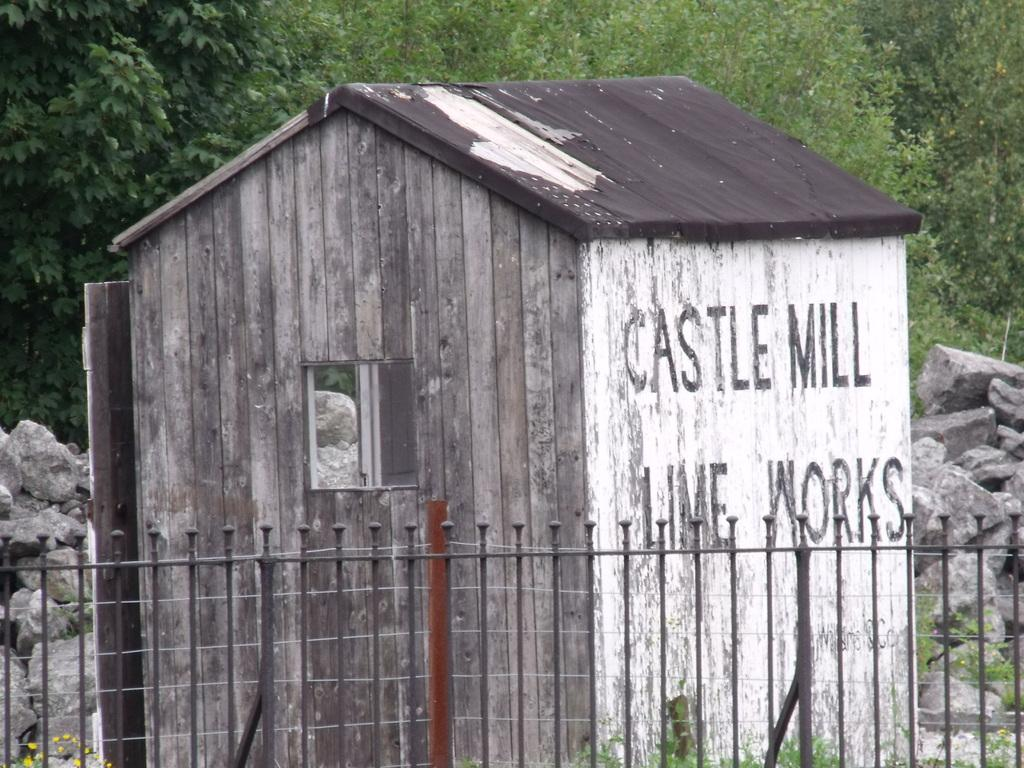<image>
Render a clear and concise summary of the photo. An old wooden building that says Castle Mill Lime Works on the side of it. 